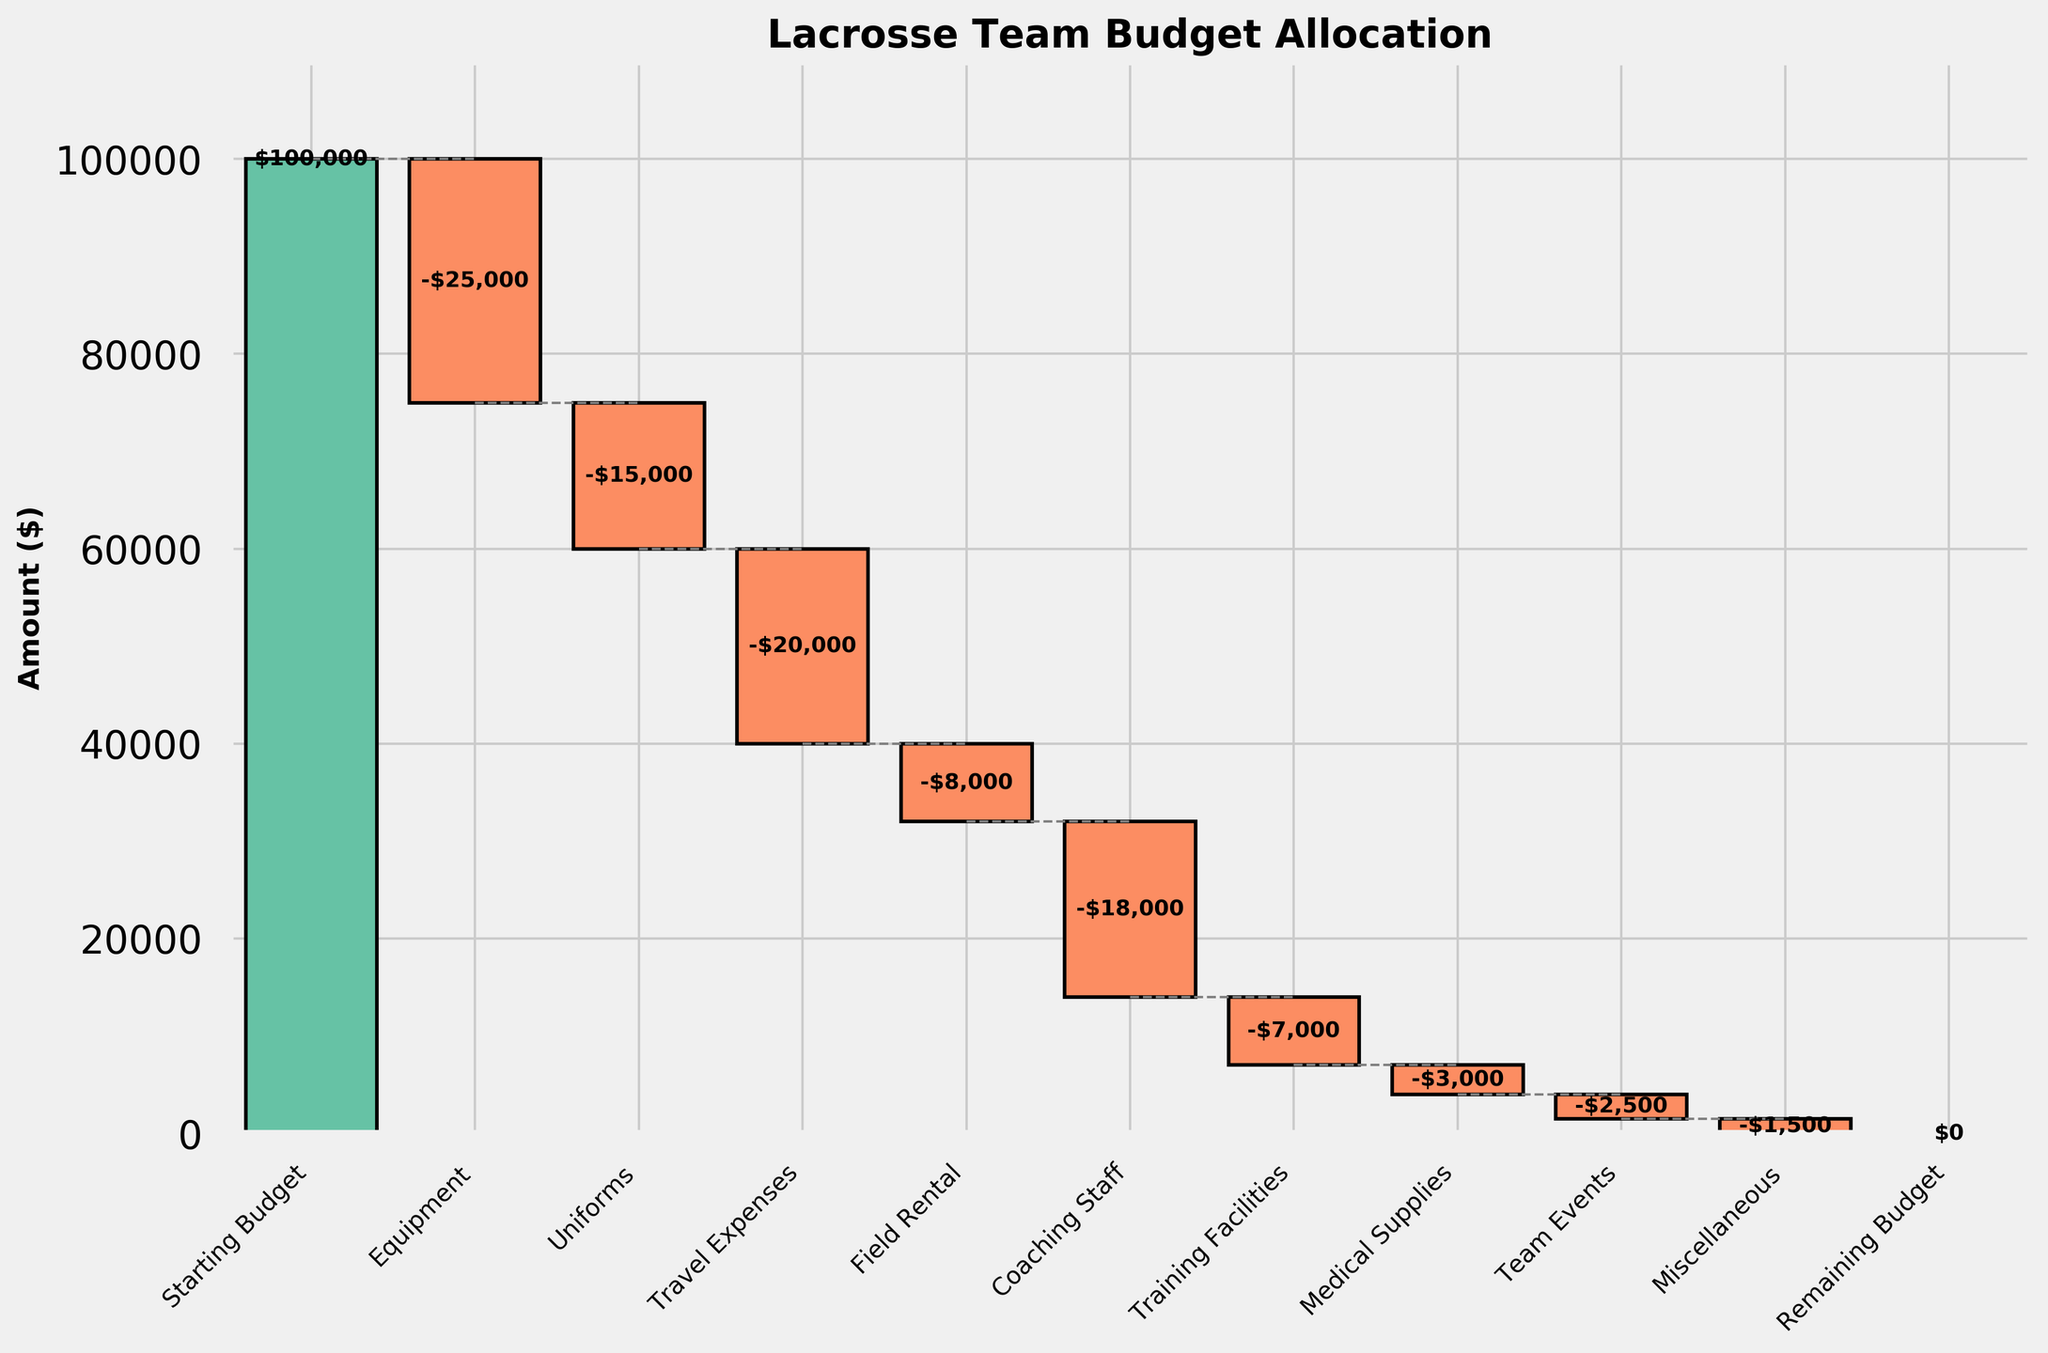What is the title of the figure? The title of the figure is displayed at the top and provides a summary of the content being visualized. The title appears as "Lacrosse Team Budget Allocation".
Answer: Lacrosse Team Budget Allocation How many categories are presented in the figure? Count the number of distinct categories listed along the x-axis. There are 11 categories including both starting and remaining budgets.
Answer: 11 Which category has the largest expense? Identify the category with the largest negative value by comparing the bar lengths on the negative side. "Equipment" has the largest negative value at -$25,000.
Answer: Equipment What is the cumulative sum after accounting for Travel Expenses? Start with the starting budget of $100,000. Subtract Equipment ($25,000), Uniforms ($15,000), and then Travel Expenses ($20,000). The cumulative sum is $40,000.
Answer: $40,000 How does the expense for Coaching Staff compare to Training Facilities? Compare the heights of the bars for these two categories. Coaching Staff has a larger expense than Training Facilities with -$18,000 compared to -$7,000.
Answer: Coaching Staff is larger What is the remaining budget after all allocations? Check the final cumulative sum indicated by the last bar in the waterfall chart. The remaining budget is $0.
Answer: $0 If Equipment costs had been $15,000, what would the remaining budget be? Start with the starting budget of $100,000. Subtract the new Equipment cost of $15,000, then continue subtracting the rest of the expenses. Sum total expenses: 15,000 + 15,000 + 20,000 + 8,000 + 18,000 + 7,000 + 3,000 + 2,500 + 1,500 = 90,000. The remaining budget would be $10,000.
Answer: $10,000 What total amount was spent on non-coaching related expenses (Equipment, Uniforms, Travel Expenses, etc.)? Add up all expenses excluding Coaching Staff: 25,000 + 15,000 + 20,000 + 8,000 + 7,000 + 3,000 + 2,500 + 1,500 = $82,000.
Answer: $82,000 What category had the smallest expense and what was its value? Identify the shortest bar with respect to its size on the negative side. "Miscellaneous" has the smallest expense of -$1,500.
Answer: Miscellaneous, -$1,500 What's the difference in cost between Equipment and Field Rental? Calculate the absolute difference between the expenses of Equipment and Field Rental: $25,000 - $8,000 = $17,000.
Answer: $17,000 